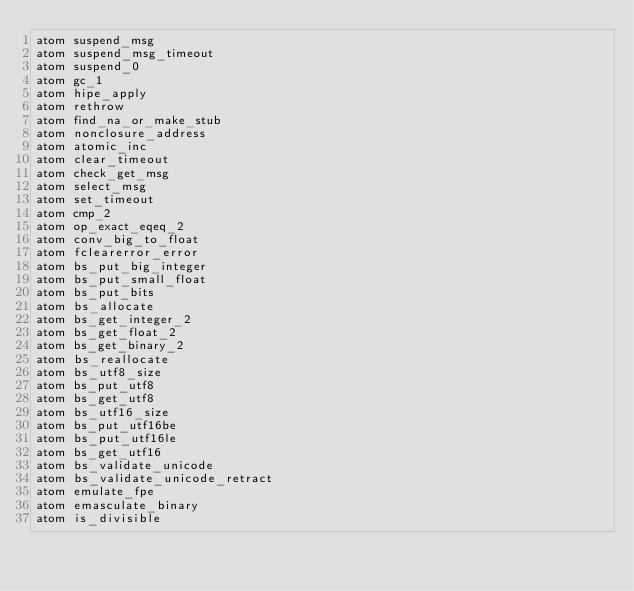<code> <loc_0><loc_0><loc_500><loc_500><_SQL_>atom suspend_msg
atom suspend_msg_timeout
atom suspend_0
atom gc_1
atom hipe_apply
atom rethrow
atom find_na_or_make_stub
atom nonclosure_address
atom atomic_inc
atom clear_timeout
atom check_get_msg
atom select_msg
atom set_timeout
atom cmp_2
atom op_exact_eqeq_2
atom conv_big_to_float
atom fclearerror_error
atom bs_put_big_integer
atom bs_put_small_float
atom bs_put_bits
atom bs_allocate
atom bs_get_integer_2
atom bs_get_float_2
atom bs_get_binary_2
atom bs_reallocate
atom bs_utf8_size
atom bs_put_utf8
atom bs_get_utf8
atom bs_utf16_size
atom bs_put_utf16be
atom bs_put_utf16le
atom bs_get_utf16
atom bs_validate_unicode
atom bs_validate_unicode_retract
atom emulate_fpe
atom emasculate_binary
atom is_divisible
</code> 